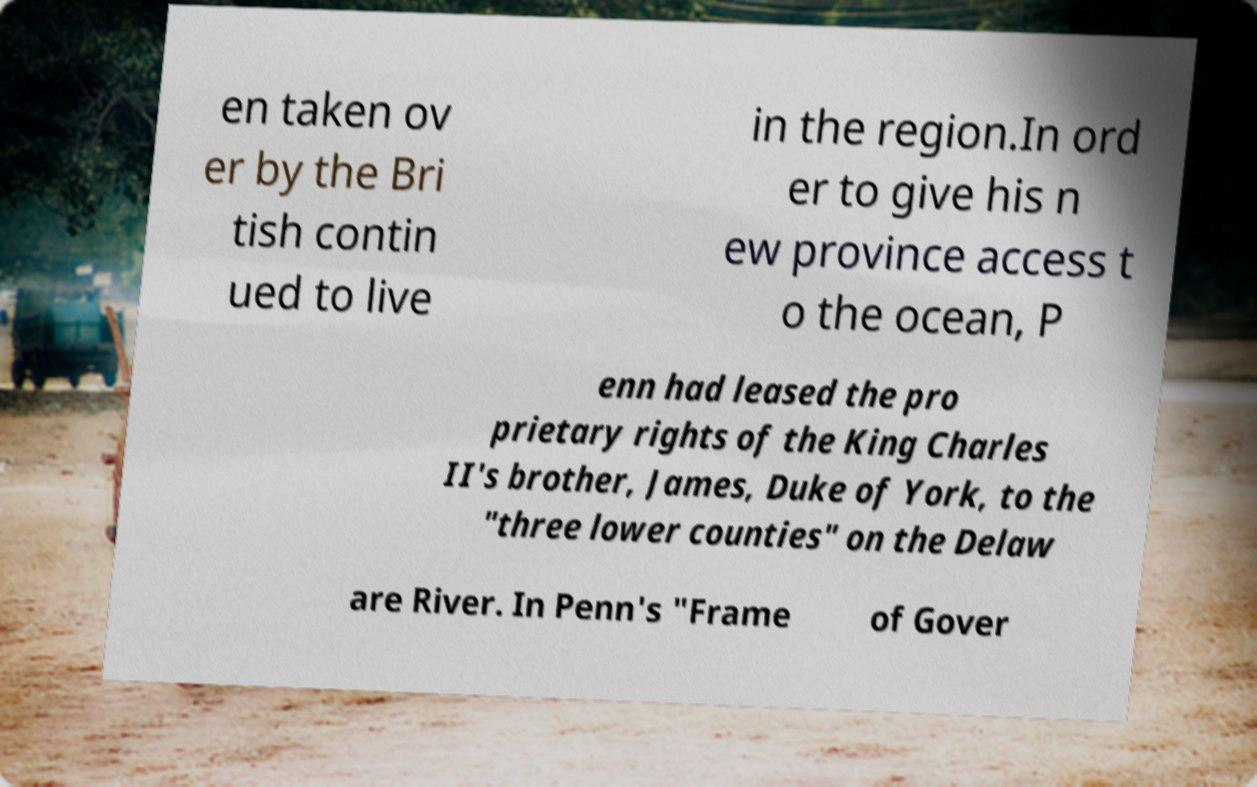Can you read and provide the text displayed in the image?This photo seems to have some interesting text. Can you extract and type it out for me? en taken ov er by the Bri tish contin ued to live in the region.In ord er to give his n ew province access t o the ocean, P enn had leased the pro prietary rights of the King Charles II's brother, James, Duke of York, to the "three lower counties" on the Delaw are River. In Penn's "Frame of Gover 